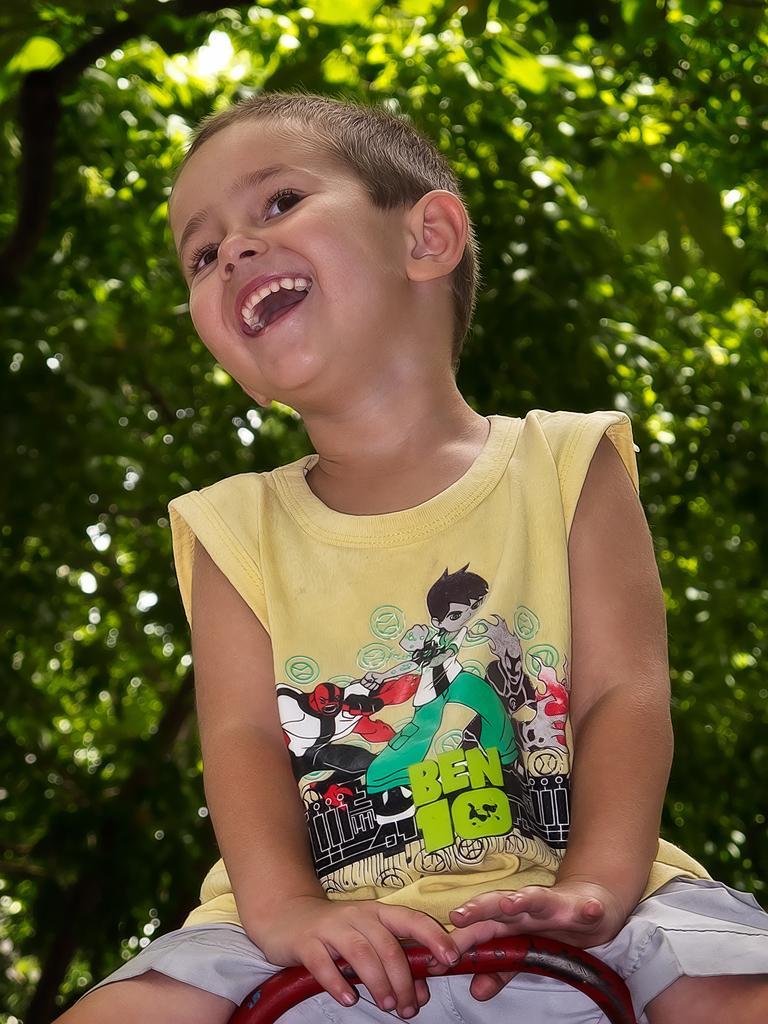How would you summarize this image in a sentence or two? Here in this picture we can see a child sitting over a place and he is smiling and behind him we can see trees present all over there. 